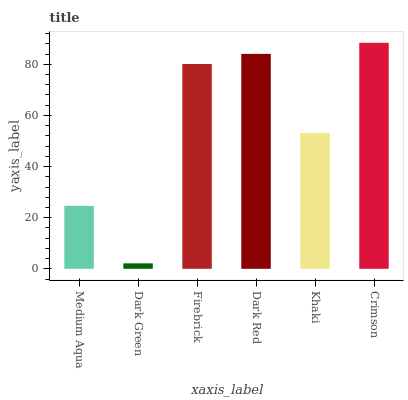Is Firebrick the minimum?
Answer yes or no. No. Is Firebrick the maximum?
Answer yes or no. No. Is Firebrick greater than Dark Green?
Answer yes or no. Yes. Is Dark Green less than Firebrick?
Answer yes or no. Yes. Is Dark Green greater than Firebrick?
Answer yes or no. No. Is Firebrick less than Dark Green?
Answer yes or no. No. Is Firebrick the high median?
Answer yes or no. Yes. Is Khaki the low median?
Answer yes or no. Yes. Is Dark Green the high median?
Answer yes or no. No. Is Dark Red the low median?
Answer yes or no. No. 